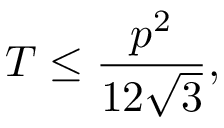<formula> <loc_0><loc_0><loc_500><loc_500>T \leq { \frac { p ^ { 2 } } { 1 2 { \sqrt { 3 } } } } ,</formula> 